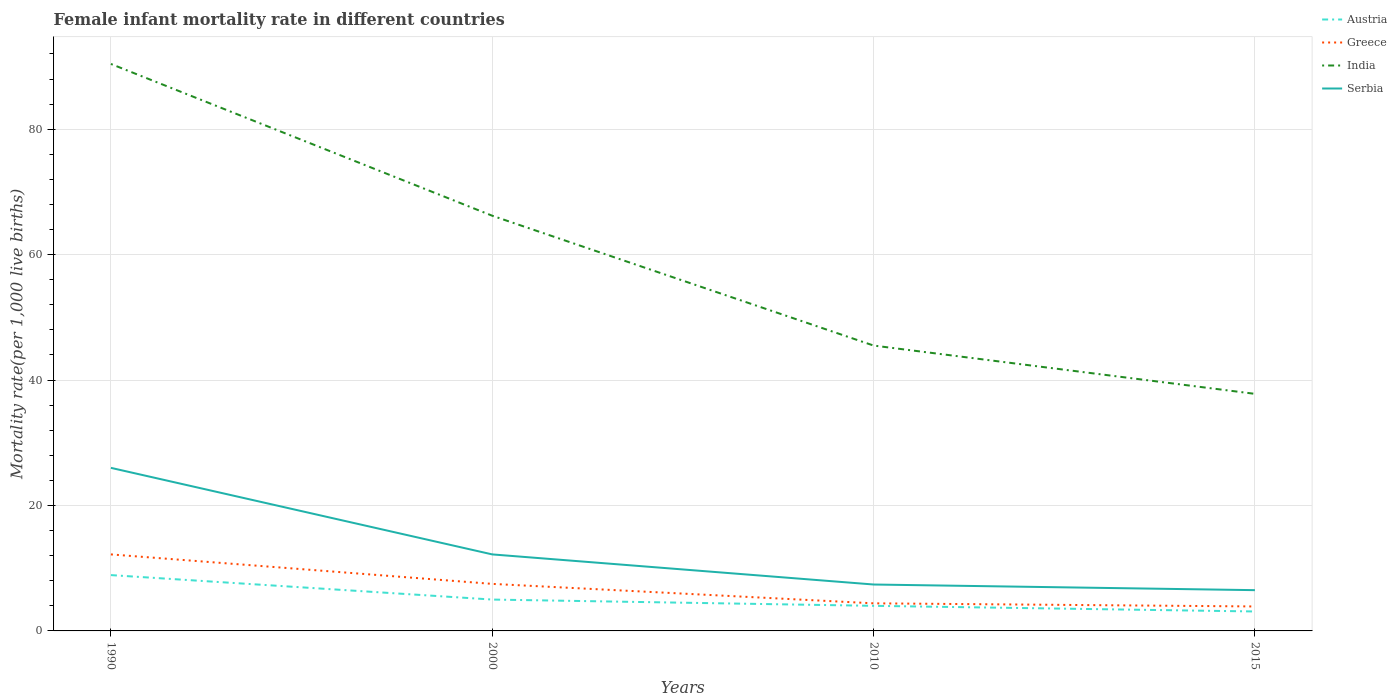Does the line corresponding to India intersect with the line corresponding to Serbia?
Offer a very short reply. No. Is the number of lines equal to the number of legend labels?
Ensure brevity in your answer.  Yes. Across all years, what is the maximum female infant mortality rate in Greece?
Make the answer very short. 3.9. In which year was the female infant mortality rate in India maximum?
Your answer should be compact. 2015. Is the female infant mortality rate in Serbia strictly greater than the female infant mortality rate in Greece over the years?
Your answer should be compact. No. What is the difference between two consecutive major ticks on the Y-axis?
Provide a short and direct response. 20. Does the graph contain any zero values?
Keep it short and to the point. No. Does the graph contain grids?
Make the answer very short. Yes. Where does the legend appear in the graph?
Offer a very short reply. Top right. How many legend labels are there?
Your answer should be compact. 4. How are the legend labels stacked?
Offer a very short reply. Vertical. What is the title of the graph?
Your answer should be very brief. Female infant mortality rate in different countries. What is the label or title of the X-axis?
Offer a very short reply. Years. What is the label or title of the Y-axis?
Provide a short and direct response. Mortality rate(per 1,0 live births). What is the Mortality rate(per 1,000 live births) in Austria in 1990?
Your response must be concise. 8.9. What is the Mortality rate(per 1,000 live births) in India in 1990?
Offer a very short reply. 90.4. What is the Mortality rate(per 1,000 live births) in Serbia in 1990?
Ensure brevity in your answer.  26. What is the Mortality rate(per 1,000 live births) in Austria in 2000?
Your answer should be very brief. 5. What is the Mortality rate(per 1,000 live births) of India in 2000?
Your answer should be very brief. 66.2. What is the Mortality rate(per 1,000 live births) of Serbia in 2000?
Provide a short and direct response. 12.2. What is the Mortality rate(per 1,000 live births) of Austria in 2010?
Keep it short and to the point. 4. What is the Mortality rate(per 1,000 live births) of Greece in 2010?
Ensure brevity in your answer.  4.4. What is the Mortality rate(per 1,000 live births) in India in 2010?
Provide a succinct answer. 45.5. What is the Mortality rate(per 1,000 live births) in Greece in 2015?
Offer a terse response. 3.9. What is the Mortality rate(per 1,000 live births) in India in 2015?
Your answer should be very brief. 37.8. Across all years, what is the maximum Mortality rate(per 1,000 live births) in Greece?
Your answer should be compact. 12.2. Across all years, what is the maximum Mortality rate(per 1,000 live births) of India?
Your answer should be compact. 90.4. Across all years, what is the minimum Mortality rate(per 1,000 live births) in Austria?
Your answer should be very brief. 3.1. Across all years, what is the minimum Mortality rate(per 1,000 live births) in Greece?
Give a very brief answer. 3.9. Across all years, what is the minimum Mortality rate(per 1,000 live births) of India?
Make the answer very short. 37.8. Across all years, what is the minimum Mortality rate(per 1,000 live births) of Serbia?
Your answer should be compact. 6.5. What is the total Mortality rate(per 1,000 live births) of Austria in the graph?
Offer a terse response. 21. What is the total Mortality rate(per 1,000 live births) of Greece in the graph?
Make the answer very short. 28. What is the total Mortality rate(per 1,000 live births) in India in the graph?
Provide a succinct answer. 239.9. What is the total Mortality rate(per 1,000 live births) of Serbia in the graph?
Offer a terse response. 52.1. What is the difference between the Mortality rate(per 1,000 live births) of India in 1990 and that in 2000?
Make the answer very short. 24.2. What is the difference between the Mortality rate(per 1,000 live births) in Austria in 1990 and that in 2010?
Your answer should be compact. 4.9. What is the difference between the Mortality rate(per 1,000 live births) of Greece in 1990 and that in 2010?
Ensure brevity in your answer.  7.8. What is the difference between the Mortality rate(per 1,000 live births) of India in 1990 and that in 2010?
Ensure brevity in your answer.  44.9. What is the difference between the Mortality rate(per 1,000 live births) of Greece in 1990 and that in 2015?
Ensure brevity in your answer.  8.3. What is the difference between the Mortality rate(per 1,000 live births) in India in 1990 and that in 2015?
Make the answer very short. 52.6. What is the difference between the Mortality rate(per 1,000 live births) of Serbia in 1990 and that in 2015?
Offer a very short reply. 19.5. What is the difference between the Mortality rate(per 1,000 live births) in Austria in 2000 and that in 2010?
Your answer should be compact. 1. What is the difference between the Mortality rate(per 1,000 live births) in Greece in 2000 and that in 2010?
Offer a very short reply. 3.1. What is the difference between the Mortality rate(per 1,000 live births) in India in 2000 and that in 2010?
Provide a short and direct response. 20.7. What is the difference between the Mortality rate(per 1,000 live births) of Serbia in 2000 and that in 2010?
Your answer should be compact. 4.8. What is the difference between the Mortality rate(per 1,000 live births) of Greece in 2000 and that in 2015?
Ensure brevity in your answer.  3.6. What is the difference between the Mortality rate(per 1,000 live births) of India in 2000 and that in 2015?
Your response must be concise. 28.4. What is the difference between the Mortality rate(per 1,000 live births) of Serbia in 2000 and that in 2015?
Your response must be concise. 5.7. What is the difference between the Mortality rate(per 1,000 live births) in Austria in 2010 and that in 2015?
Keep it short and to the point. 0.9. What is the difference between the Mortality rate(per 1,000 live births) in Serbia in 2010 and that in 2015?
Offer a terse response. 0.9. What is the difference between the Mortality rate(per 1,000 live births) of Austria in 1990 and the Mortality rate(per 1,000 live births) of Greece in 2000?
Keep it short and to the point. 1.4. What is the difference between the Mortality rate(per 1,000 live births) of Austria in 1990 and the Mortality rate(per 1,000 live births) of India in 2000?
Provide a short and direct response. -57.3. What is the difference between the Mortality rate(per 1,000 live births) in Greece in 1990 and the Mortality rate(per 1,000 live births) in India in 2000?
Ensure brevity in your answer.  -54. What is the difference between the Mortality rate(per 1,000 live births) of Greece in 1990 and the Mortality rate(per 1,000 live births) of Serbia in 2000?
Your response must be concise. 0. What is the difference between the Mortality rate(per 1,000 live births) in India in 1990 and the Mortality rate(per 1,000 live births) in Serbia in 2000?
Provide a succinct answer. 78.2. What is the difference between the Mortality rate(per 1,000 live births) of Austria in 1990 and the Mortality rate(per 1,000 live births) of India in 2010?
Offer a terse response. -36.6. What is the difference between the Mortality rate(per 1,000 live births) of Austria in 1990 and the Mortality rate(per 1,000 live births) of Serbia in 2010?
Ensure brevity in your answer.  1.5. What is the difference between the Mortality rate(per 1,000 live births) in Greece in 1990 and the Mortality rate(per 1,000 live births) in India in 2010?
Your answer should be compact. -33.3. What is the difference between the Mortality rate(per 1,000 live births) in India in 1990 and the Mortality rate(per 1,000 live births) in Serbia in 2010?
Provide a succinct answer. 83. What is the difference between the Mortality rate(per 1,000 live births) of Austria in 1990 and the Mortality rate(per 1,000 live births) of Greece in 2015?
Give a very brief answer. 5. What is the difference between the Mortality rate(per 1,000 live births) of Austria in 1990 and the Mortality rate(per 1,000 live births) of India in 2015?
Give a very brief answer. -28.9. What is the difference between the Mortality rate(per 1,000 live births) of Greece in 1990 and the Mortality rate(per 1,000 live births) of India in 2015?
Your response must be concise. -25.6. What is the difference between the Mortality rate(per 1,000 live births) of India in 1990 and the Mortality rate(per 1,000 live births) of Serbia in 2015?
Ensure brevity in your answer.  83.9. What is the difference between the Mortality rate(per 1,000 live births) of Austria in 2000 and the Mortality rate(per 1,000 live births) of Greece in 2010?
Ensure brevity in your answer.  0.6. What is the difference between the Mortality rate(per 1,000 live births) in Austria in 2000 and the Mortality rate(per 1,000 live births) in India in 2010?
Offer a terse response. -40.5. What is the difference between the Mortality rate(per 1,000 live births) in Greece in 2000 and the Mortality rate(per 1,000 live births) in India in 2010?
Provide a short and direct response. -38. What is the difference between the Mortality rate(per 1,000 live births) in India in 2000 and the Mortality rate(per 1,000 live births) in Serbia in 2010?
Give a very brief answer. 58.8. What is the difference between the Mortality rate(per 1,000 live births) of Austria in 2000 and the Mortality rate(per 1,000 live births) of Greece in 2015?
Your answer should be compact. 1.1. What is the difference between the Mortality rate(per 1,000 live births) in Austria in 2000 and the Mortality rate(per 1,000 live births) in India in 2015?
Give a very brief answer. -32.8. What is the difference between the Mortality rate(per 1,000 live births) in Greece in 2000 and the Mortality rate(per 1,000 live births) in India in 2015?
Make the answer very short. -30.3. What is the difference between the Mortality rate(per 1,000 live births) of Greece in 2000 and the Mortality rate(per 1,000 live births) of Serbia in 2015?
Your answer should be very brief. 1. What is the difference between the Mortality rate(per 1,000 live births) of India in 2000 and the Mortality rate(per 1,000 live births) of Serbia in 2015?
Your answer should be very brief. 59.7. What is the difference between the Mortality rate(per 1,000 live births) in Austria in 2010 and the Mortality rate(per 1,000 live births) in Greece in 2015?
Make the answer very short. 0.1. What is the difference between the Mortality rate(per 1,000 live births) in Austria in 2010 and the Mortality rate(per 1,000 live births) in India in 2015?
Your response must be concise. -33.8. What is the difference between the Mortality rate(per 1,000 live births) of Austria in 2010 and the Mortality rate(per 1,000 live births) of Serbia in 2015?
Provide a succinct answer. -2.5. What is the difference between the Mortality rate(per 1,000 live births) of Greece in 2010 and the Mortality rate(per 1,000 live births) of India in 2015?
Your answer should be very brief. -33.4. What is the difference between the Mortality rate(per 1,000 live births) in Greece in 2010 and the Mortality rate(per 1,000 live births) in Serbia in 2015?
Your answer should be compact. -2.1. What is the average Mortality rate(per 1,000 live births) of Austria per year?
Ensure brevity in your answer.  5.25. What is the average Mortality rate(per 1,000 live births) in India per year?
Offer a very short reply. 59.98. What is the average Mortality rate(per 1,000 live births) of Serbia per year?
Your answer should be compact. 13.03. In the year 1990, what is the difference between the Mortality rate(per 1,000 live births) in Austria and Mortality rate(per 1,000 live births) in India?
Offer a terse response. -81.5. In the year 1990, what is the difference between the Mortality rate(per 1,000 live births) of Austria and Mortality rate(per 1,000 live births) of Serbia?
Offer a very short reply. -17.1. In the year 1990, what is the difference between the Mortality rate(per 1,000 live births) in Greece and Mortality rate(per 1,000 live births) in India?
Provide a short and direct response. -78.2. In the year 1990, what is the difference between the Mortality rate(per 1,000 live births) in India and Mortality rate(per 1,000 live births) in Serbia?
Your answer should be very brief. 64.4. In the year 2000, what is the difference between the Mortality rate(per 1,000 live births) of Austria and Mortality rate(per 1,000 live births) of Greece?
Make the answer very short. -2.5. In the year 2000, what is the difference between the Mortality rate(per 1,000 live births) of Austria and Mortality rate(per 1,000 live births) of India?
Offer a very short reply. -61.2. In the year 2000, what is the difference between the Mortality rate(per 1,000 live births) in Greece and Mortality rate(per 1,000 live births) in India?
Make the answer very short. -58.7. In the year 2000, what is the difference between the Mortality rate(per 1,000 live births) in Greece and Mortality rate(per 1,000 live births) in Serbia?
Offer a very short reply. -4.7. In the year 2000, what is the difference between the Mortality rate(per 1,000 live births) in India and Mortality rate(per 1,000 live births) in Serbia?
Keep it short and to the point. 54. In the year 2010, what is the difference between the Mortality rate(per 1,000 live births) of Austria and Mortality rate(per 1,000 live births) of India?
Provide a short and direct response. -41.5. In the year 2010, what is the difference between the Mortality rate(per 1,000 live births) in Austria and Mortality rate(per 1,000 live births) in Serbia?
Ensure brevity in your answer.  -3.4. In the year 2010, what is the difference between the Mortality rate(per 1,000 live births) in Greece and Mortality rate(per 1,000 live births) in India?
Offer a terse response. -41.1. In the year 2010, what is the difference between the Mortality rate(per 1,000 live births) of India and Mortality rate(per 1,000 live births) of Serbia?
Make the answer very short. 38.1. In the year 2015, what is the difference between the Mortality rate(per 1,000 live births) of Austria and Mortality rate(per 1,000 live births) of Greece?
Provide a short and direct response. -0.8. In the year 2015, what is the difference between the Mortality rate(per 1,000 live births) in Austria and Mortality rate(per 1,000 live births) in India?
Give a very brief answer. -34.7. In the year 2015, what is the difference between the Mortality rate(per 1,000 live births) of Greece and Mortality rate(per 1,000 live births) of India?
Your answer should be compact. -33.9. In the year 2015, what is the difference between the Mortality rate(per 1,000 live births) in India and Mortality rate(per 1,000 live births) in Serbia?
Offer a terse response. 31.3. What is the ratio of the Mortality rate(per 1,000 live births) of Austria in 1990 to that in 2000?
Provide a succinct answer. 1.78. What is the ratio of the Mortality rate(per 1,000 live births) of Greece in 1990 to that in 2000?
Provide a succinct answer. 1.63. What is the ratio of the Mortality rate(per 1,000 live births) of India in 1990 to that in 2000?
Your answer should be very brief. 1.37. What is the ratio of the Mortality rate(per 1,000 live births) in Serbia in 1990 to that in 2000?
Your response must be concise. 2.13. What is the ratio of the Mortality rate(per 1,000 live births) in Austria in 1990 to that in 2010?
Give a very brief answer. 2.23. What is the ratio of the Mortality rate(per 1,000 live births) of Greece in 1990 to that in 2010?
Provide a succinct answer. 2.77. What is the ratio of the Mortality rate(per 1,000 live births) in India in 1990 to that in 2010?
Keep it short and to the point. 1.99. What is the ratio of the Mortality rate(per 1,000 live births) of Serbia in 1990 to that in 2010?
Your answer should be very brief. 3.51. What is the ratio of the Mortality rate(per 1,000 live births) in Austria in 1990 to that in 2015?
Your answer should be very brief. 2.87. What is the ratio of the Mortality rate(per 1,000 live births) in Greece in 1990 to that in 2015?
Provide a short and direct response. 3.13. What is the ratio of the Mortality rate(per 1,000 live births) of India in 1990 to that in 2015?
Provide a succinct answer. 2.39. What is the ratio of the Mortality rate(per 1,000 live births) of Greece in 2000 to that in 2010?
Give a very brief answer. 1.7. What is the ratio of the Mortality rate(per 1,000 live births) in India in 2000 to that in 2010?
Provide a succinct answer. 1.45. What is the ratio of the Mortality rate(per 1,000 live births) in Serbia in 2000 to that in 2010?
Offer a very short reply. 1.65. What is the ratio of the Mortality rate(per 1,000 live births) in Austria in 2000 to that in 2015?
Provide a succinct answer. 1.61. What is the ratio of the Mortality rate(per 1,000 live births) of Greece in 2000 to that in 2015?
Offer a terse response. 1.92. What is the ratio of the Mortality rate(per 1,000 live births) in India in 2000 to that in 2015?
Give a very brief answer. 1.75. What is the ratio of the Mortality rate(per 1,000 live births) in Serbia in 2000 to that in 2015?
Keep it short and to the point. 1.88. What is the ratio of the Mortality rate(per 1,000 live births) in Austria in 2010 to that in 2015?
Make the answer very short. 1.29. What is the ratio of the Mortality rate(per 1,000 live births) of Greece in 2010 to that in 2015?
Give a very brief answer. 1.13. What is the ratio of the Mortality rate(per 1,000 live births) in India in 2010 to that in 2015?
Keep it short and to the point. 1.2. What is the ratio of the Mortality rate(per 1,000 live births) of Serbia in 2010 to that in 2015?
Offer a terse response. 1.14. What is the difference between the highest and the second highest Mortality rate(per 1,000 live births) in Greece?
Provide a short and direct response. 4.7. What is the difference between the highest and the second highest Mortality rate(per 1,000 live births) in India?
Provide a short and direct response. 24.2. What is the difference between the highest and the lowest Mortality rate(per 1,000 live births) in Austria?
Your response must be concise. 5.8. What is the difference between the highest and the lowest Mortality rate(per 1,000 live births) in Greece?
Give a very brief answer. 8.3. What is the difference between the highest and the lowest Mortality rate(per 1,000 live births) of India?
Keep it short and to the point. 52.6. 